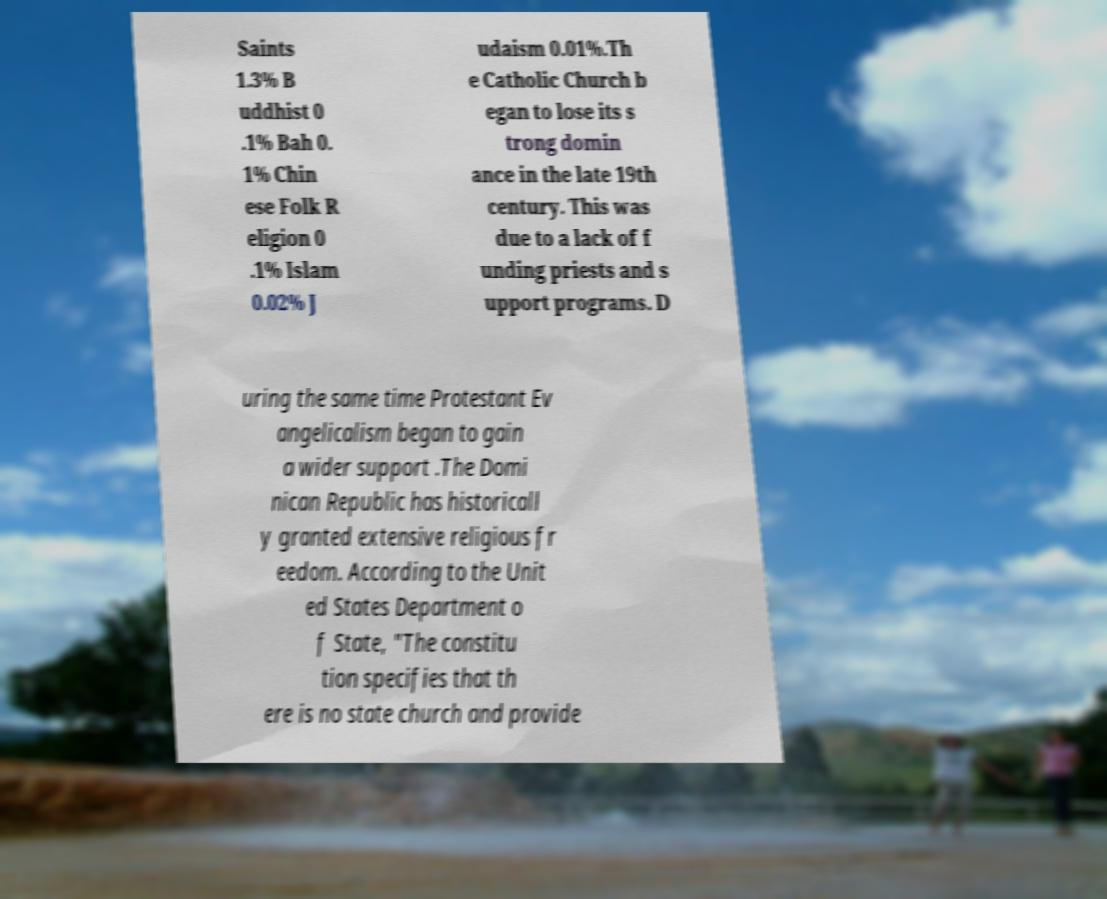What messages or text are displayed in this image? I need them in a readable, typed format. Saints 1.3% B uddhist 0 .1% Bah 0. 1% Chin ese Folk R eligion 0 .1% Islam 0.02% J udaism 0.01%.Th e Catholic Church b egan to lose its s trong domin ance in the late 19th century. This was due to a lack of f unding priests and s upport programs. D uring the same time Protestant Ev angelicalism began to gain a wider support .The Domi nican Republic has historicall y granted extensive religious fr eedom. According to the Unit ed States Department o f State, "The constitu tion specifies that th ere is no state church and provide 